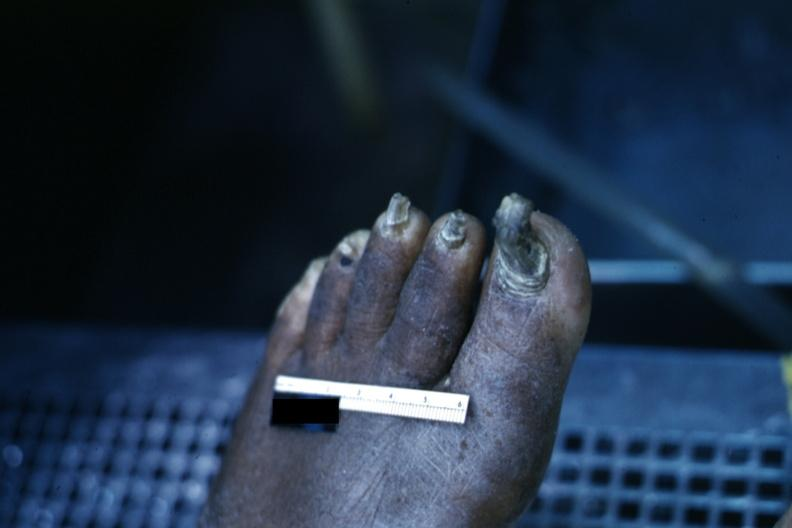re view looking down on heads present?
Answer the question using a single word or phrase. No 